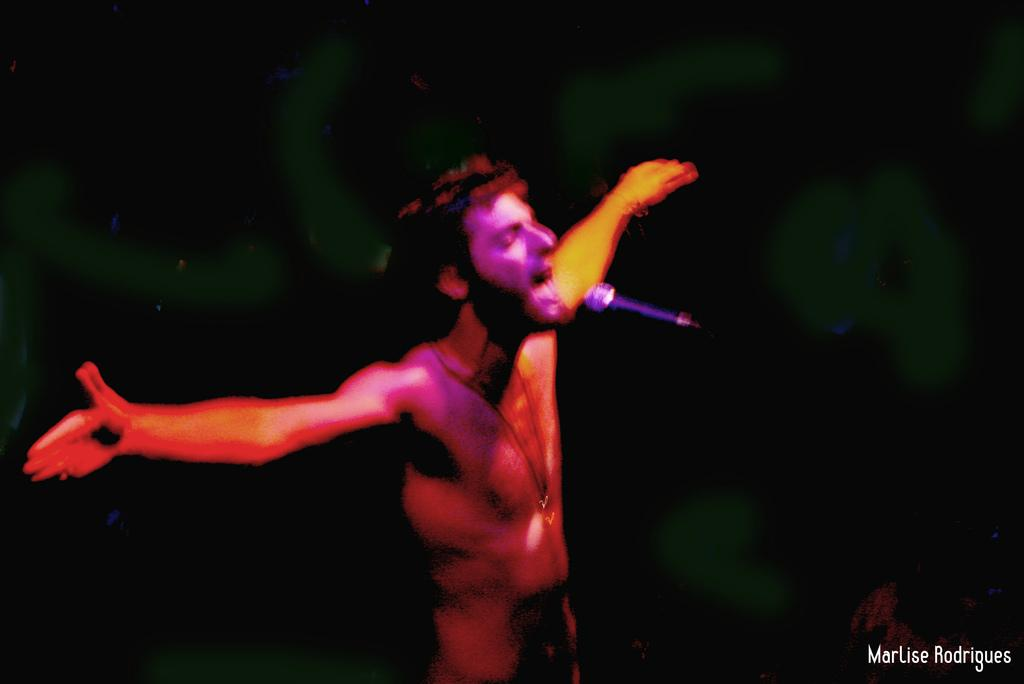What is the main subject of the image? There is a person standing in the image. What object is visible near the person? There is a microphone (mic) in the image. What colors are used in the background of the image? The background of the image is in black and green colors. Can you tell me how many toads are visible in the image? There are no toads present in the image. What type of land can be seen in the background of the image? The background of the image does not show any land; it is in black and green colors. 